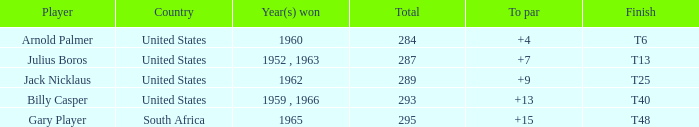Which american player achieved victory in 1962? Jack Nicklaus. 